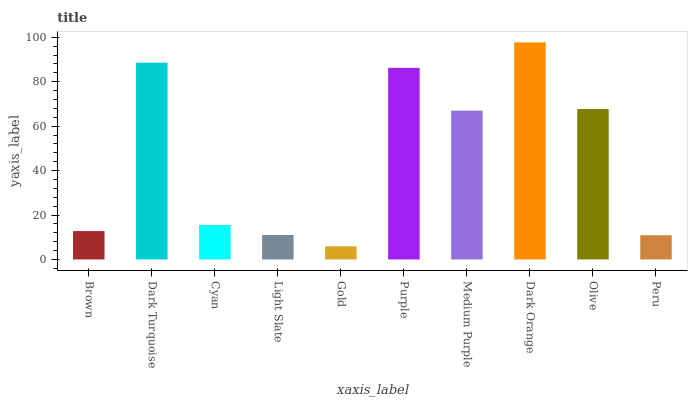Is Gold the minimum?
Answer yes or no. Yes. Is Dark Orange the maximum?
Answer yes or no. Yes. Is Dark Turquoise the minimum?
Answer yes or no. No. Is Dark Turquoise the maximum?
Answer yes or no. No. Is Dark Turquoise greater than Brown?
Answer yes or no. Yes. Is Brown less than Dark Turquoise?
Answer yes or no. Yes. Is Brown greater than Dark Turquoise?
Answer yes or no. No. Is Dark Turquoise less than Brown?
Answer yes or no. No. Is Medium Purple the high median?
Answer yes or no. Yes. Is Cyan the low median?
Answer yes or no. Yes. Is Gold the high median?
Answer yes or no. No. Is Brown the low median?
Answer yes or no. No. 